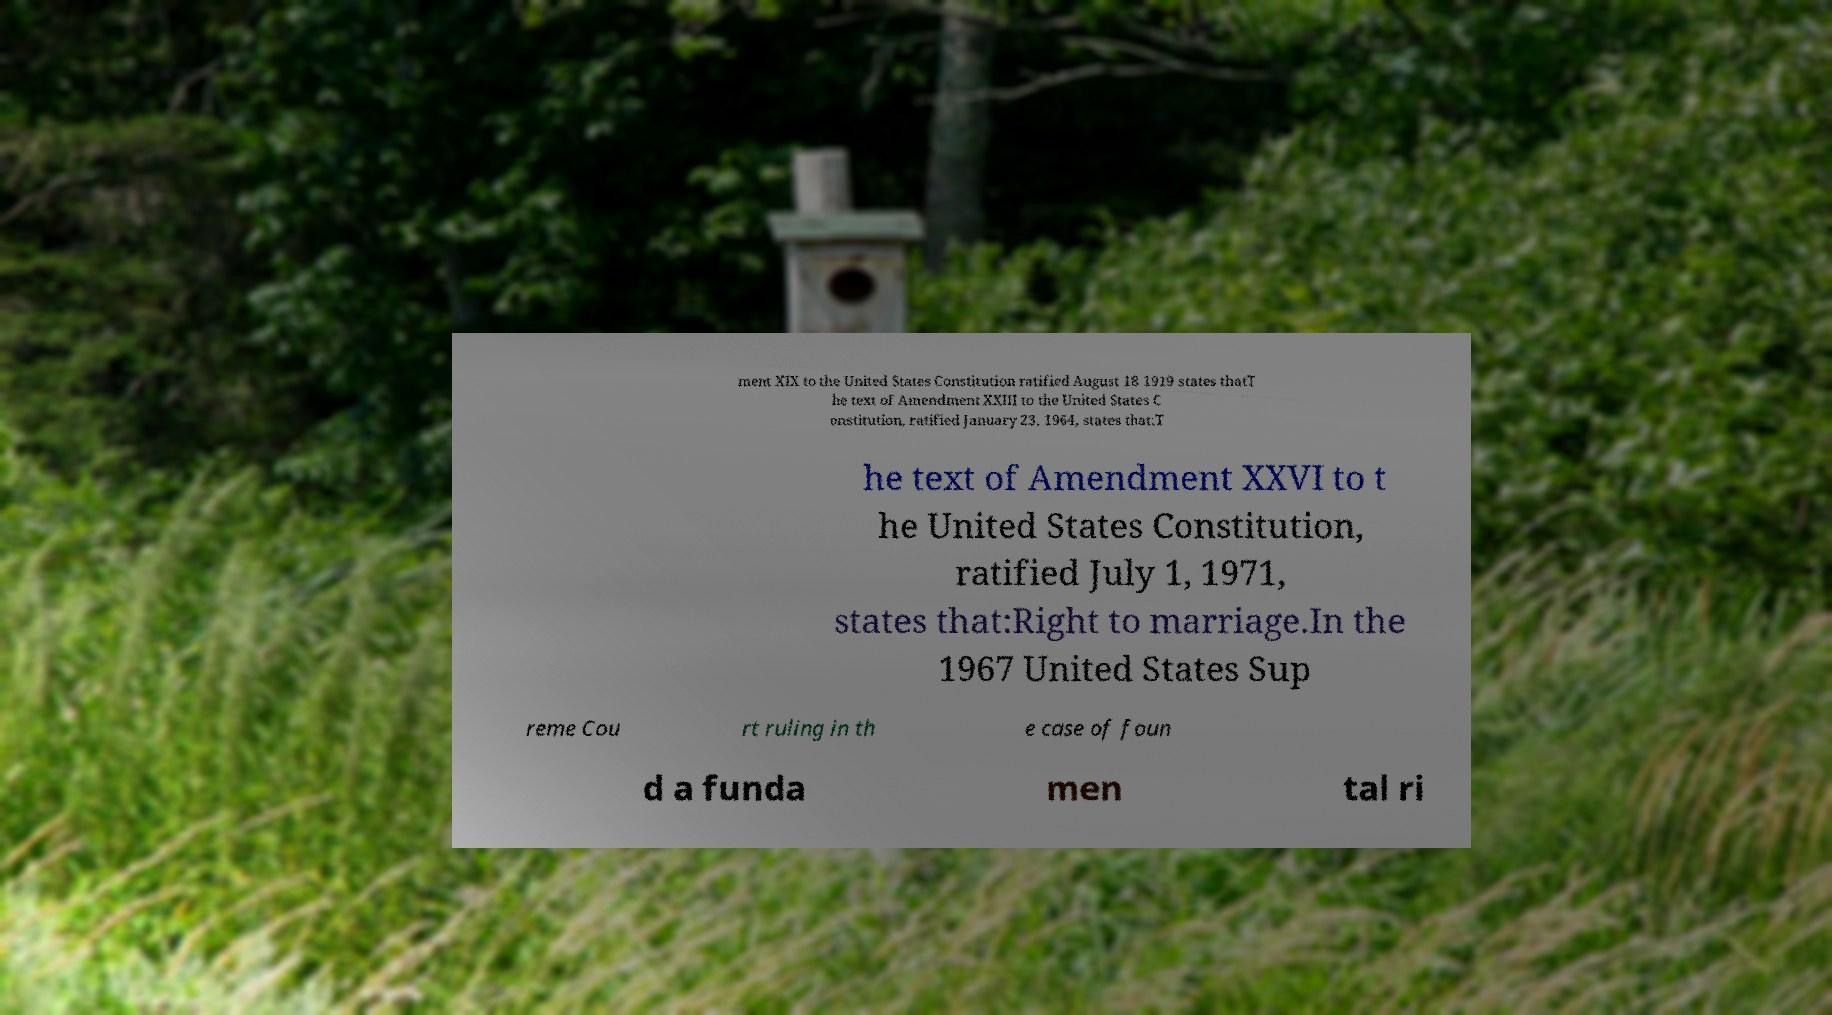Can you accurately transcribe the text from the provided image for me? ment XIX to the United States Constitution ratified August 18 1919 states thatT he text of Amendment XXIII to the United States C onstitution, ratified January 23, 1964, states that:T he text of Amendment XXVI to t he United States Constitution, ratified July 1, 1971, states that:Right to marriage.In the 1967 United States Sup reme Cou rt ruling in th e case of foun d a funda men tal ri 